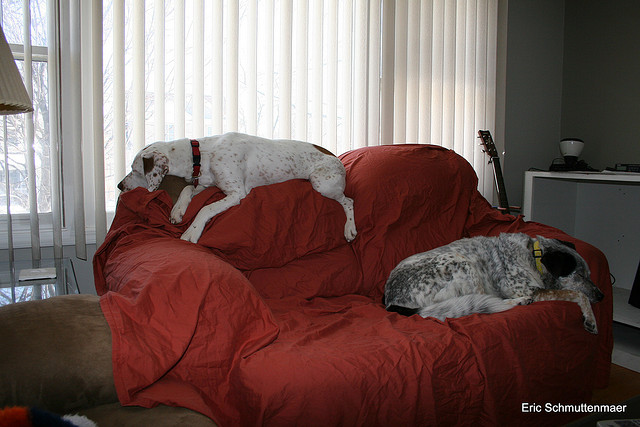Identify the text contained in this image. Eric Schmuttenmaer 